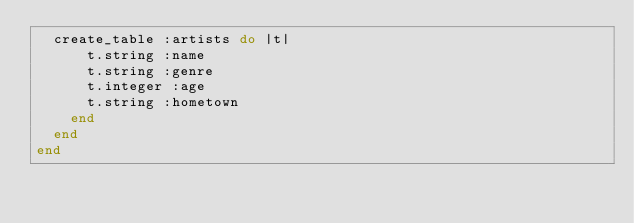<code> <loc_0><loc_0><loc_500><loc_500><_Ruby_>  create_table :artists do |t|
      t.string :name
      t.string :genre
      t.integer :age
      t.string :hometown
    end
  end
end</code> 